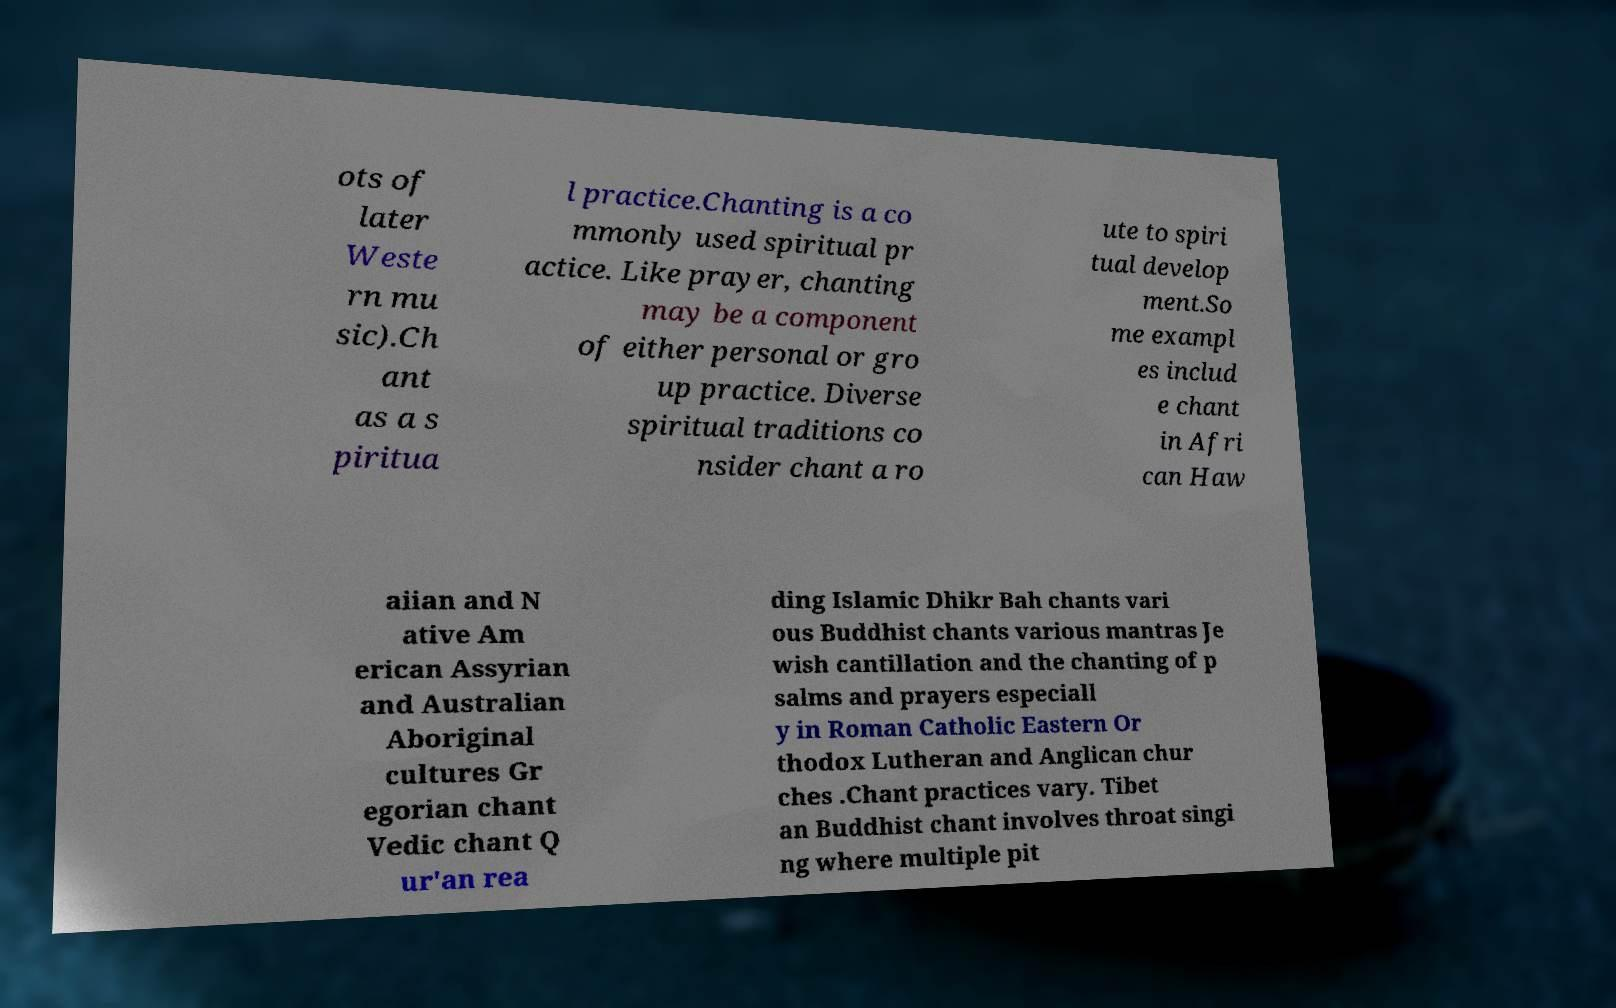Please identify and transcribe the text found in this image. ots of later Weste rn mu sic).Ch ant as a s piritua l practice.Chanting is a co mmonly used spiritual pr actice. Like prayer, chanting may be a component of either personal or gro up practice. Diverse spiritual traditions co nsider chant a ro ute to spiri tual develop ment.So me exampl es includ e chant in Afri can Haw aiian and N ative Am erican Assyrian and Australian Aboriginal cultures Gr egorian chant Vedic chant Q ur'an rea ding Islamic Dhikr Bah chants vari ous Buddhist chants various mantras Je wish cantillation and the chanting of p salms and prayers especiall y in Roman Catholic Eastern Or thodox Lutheran and Anglican chur ches .Chant practices vary. Tibet an Buddhist chant involves throat singi ng where multiple pit 